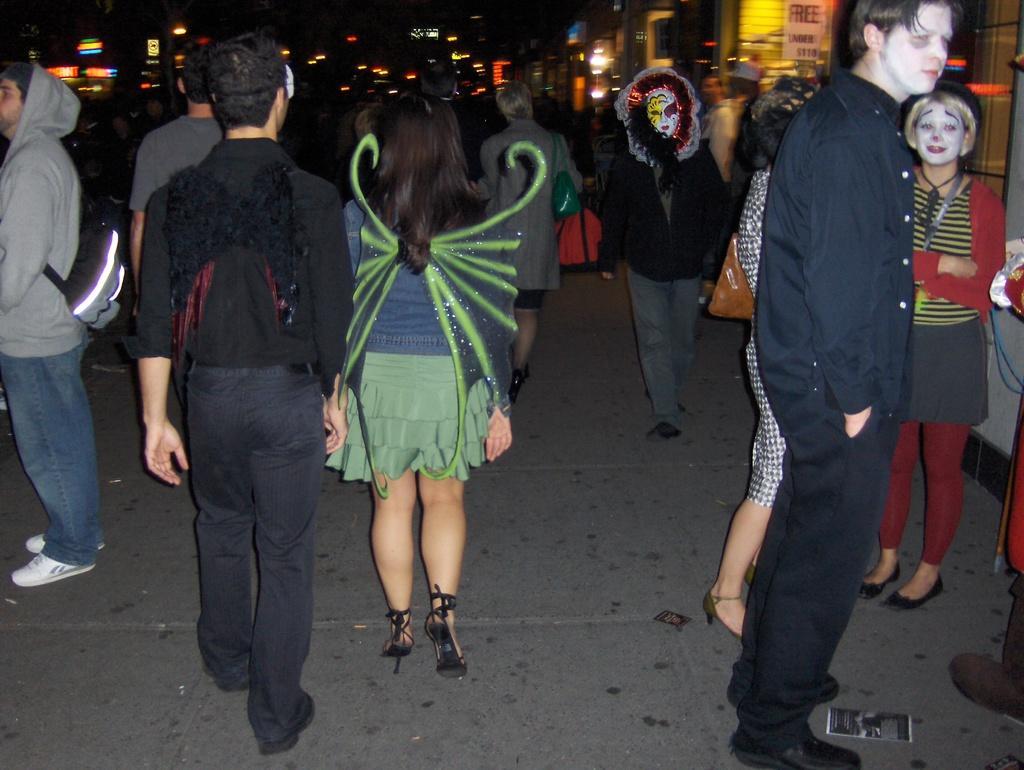How would you summarize this image in a sentence or two? In the foreground, I can see a crowd on the road. In the background, I can see buildings, boards, lights and a dark color. This image taken, maybe during night. 